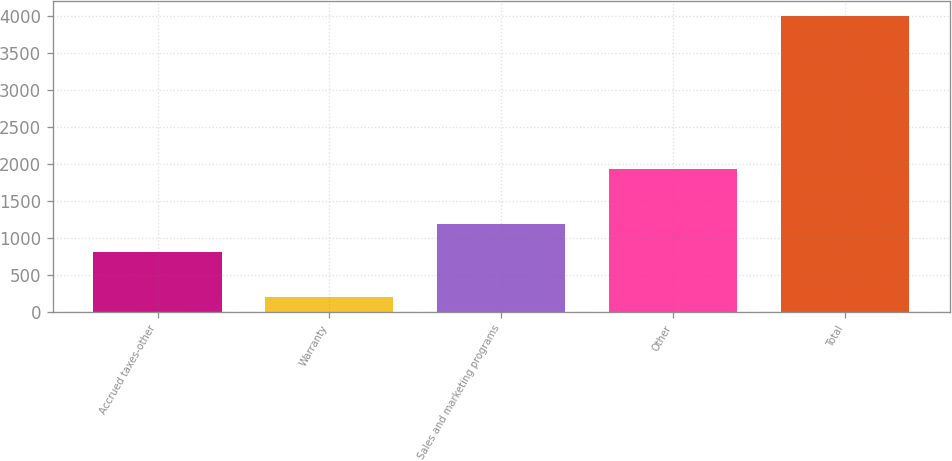Convert chart to OTSL. <chart><loc_0><loc_0><loc_500><loc_500><bar_chart><fcel>Accrued taxes-other<fcel>Warranty<fcel>Sales and marketing programs<fcel>Other<fcel>Total<nl><fcel>806<fcel>199<fcel>1186.3<fcel>1932<fcel>4002<nl></chart> 